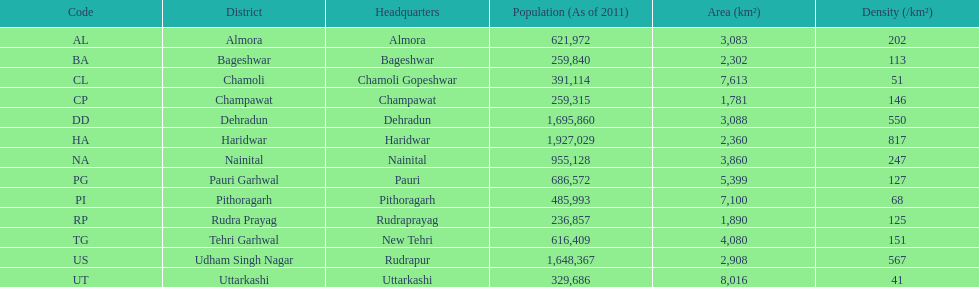If a person was headquartered in almora what would be his/her district? Almora. 